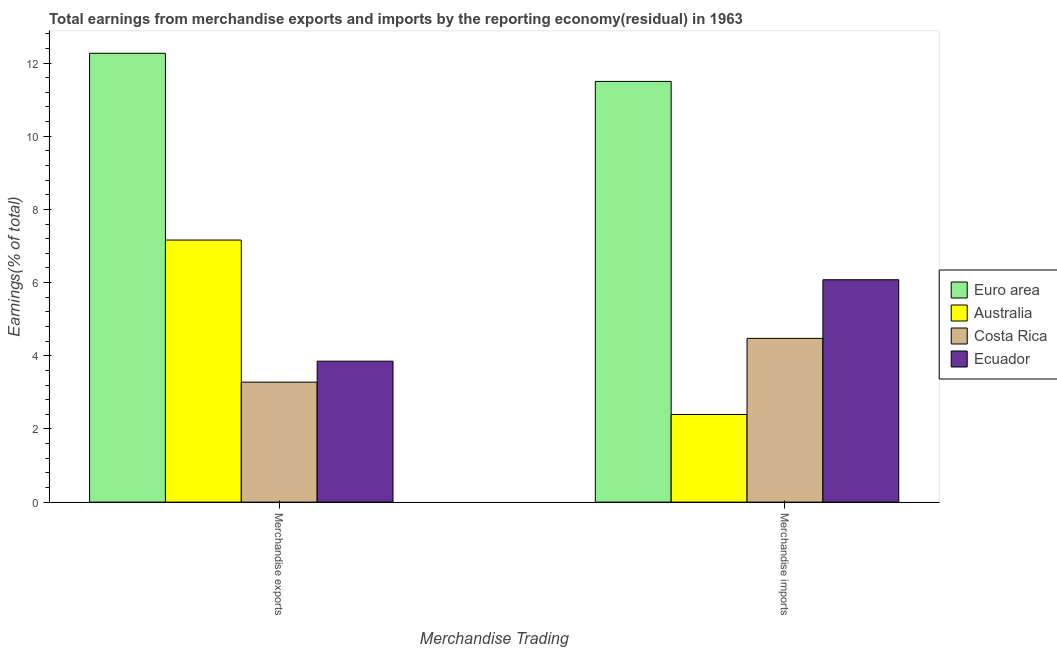How many different coloured bars are there?
Ensure brevity in your answer.  4. How many groups of bars are there?
Your answer should be very brief. 2. Are the number of bars per tick equal to the number of legend labels?
Offer a terse response. Yes. What is the earnings from merchandise exports in Euro area?
Offer a very short reply. 12.27. Across all countries, what is the maximum earnings from merchandise exports?
Your answer should be compact. 12.27. Across all countries, what is the minimum earnings from merchandise imports?
Provide a succinct answer. 2.4. In which country was the earnings from merchandise exports minimum?
Your answer should be compact. Costa Rica. What is the total earnings from merchandise imports in the graph?
Give a very brief answer. 24.45. What is the difference between the earnings from merchandise exports in Ecuador and that in Australia?
Keep it short and to the point. -3.31. What is the difference between the earnings from merchandise imports in Costa Rica and the earnings from merchandise exports in Australia?
Your response must be concise. -2.69. What is the average earnings from merchandise exports per country?
Offer a very short reply. 6.64. What is the difference between the earnings from merchandise imports and earnings from merchandise exports in Ecuador?
Offer a terse response. 2.23. What is the ratio of the earnings from merchandise exports in Costa Rica to that in Ecuador?
Provide a succinct answer. 0.85. How many countries are there in the graph?
Offer a very short reply. 4. Does the graph contain any zero values?
Provide a short and direct response. No. Where does the legend appear in the graph?
Give a very brief answer. Center right. How many legend labels are there?
Make the answer very short. 4. How are the legend labels stacked?
Your answer should be compact. Vertical. What is the title of the graph?
Provide a short and direct response. Total earnings from merchandise exports and imports by the reporting economy(residual) in 1963. What is the label or title of the X-axis?
Your answer should be compact. Merchandise Trading. What is the label or title of the Y-axis?
Your answer should be compact. Earnings(% of total). What is the Earnings(% of total) of Euro area in Merchandise exports?
Make the answer very short. 12.27. What is the Earnings(% of total) in Australia in Merchandise exports?
Your response must be concise. 7.16. What is the Earnings(% of total) of Costa Rica in Merchandise exports?
Make the answer very short. 3.28. What is the Earnings(% of total) in Ecuador in Merchandise exports?
Give a very brief answer. 3.85. What is the Earnings(% of total) in Euro area in Merchandise imports?
Offer a very short reply. 11.5. What is the Earnings(% of total) in Australia in Merchandise imports?
Ensure brevity in your answer.  2.4. What is the Earnings(% of total) in Costa Rica in Merchandise imports?
Make the answer very short. 4.48. What is the Earnings(% of total) in Ecuador in Merchandise imports?
Keep it short and to the point. 6.08. Across all Merchandise Trading, what is the maximum Earnings(% of total) of Euro area?
Your answer should be very brief. 12.27. Across all Merchandise Trading, what is the maximum Earnings(% of total) in Australia?
Keep it short and to the point. 7.16. Across all Merchandise Trading, what is the maximum Earnings(% of total) in Costa Rica?
Give a very brief answer. 4.48. Across all Merchandise Trading, what is the maximum Earnings(% of total) of Ecuador?
Make the answer very short. 6.08. Across all Merchandise Trading, what is the minimum Earnings(% of total) of Euro area?
Offer a very short reply. 11.5. Across all Merchandise Trading, what is the minimum Earnings(% of total) of Australia?
Provide a short and direct response. 2.4. Across all Merchandise Trading, what is the minimum Earnings(% of total) of Costa Rica?
Your response must be concise. 3.28. Across all Merchandise Trading, what is the minimum Earnings(% of total) of Ecuador?
Provide a short and direct response. 3.85. What is the total Earnings(% of total) in Euro area in the graph?
Your response must be concise. 23.76. What is the total Earnings(% of total) of Australia in the graph?
Keep it short and to the point. 9.56. What is the total Earnings(% of total) in Costa Rica in the graph?
Give a very brief answer. 7.75. What is the total Earnings(% of total) in Ecuador in the graph?
Provide a short and direct response. 9.93. What is the difference between the Earnings(% of total) of Euro area in Merchandise exports and that in Merchandise imports?
Your answer should be compact. 0.77. What is the difference between the Earnings(% of total) of Australia in Merchandise exports and that in Merchandise imports?
Offer a terse response. 4.77. What is the difference between the Earnings(% of total) in Costa Rica in Merchandise exports and that in Merchandise imports?
Your answer should be compact. -1.2. What is the difference between the Earnings(% of total) of Ecuador in Merchandise exports and that in Merchandise imports?
Provide a succinct answer. -2.23. What is the difference between the Earnings(% of total) in Euro area in Merchandise exports and the Earnings(% of total) in Australia in Merchandise imports?
Provide a short and direct response. 9.87. What is the difference between the Earnings(% of total) in Euro area in Merchandise exports and the Earnings(% of total) in Costa Rica in Merchandise imports?
Make the answer very short. 7.79. What is the difference between the Earnings(% of total) in Euro area in Merchandise exports and the Earnings(% of total) in Ecuador in Merchandise imports?
Provide a succinct answer. 6.19. What is the difference between the Earnings(% of total) in Australia in Merchandise exports and the Earnings(% of total) in Costa Rica in Merchandise imports?
Offer a terse response. 2.69. What is the difference between the Earnings(% of total) of Australia in Merchandise exports and the Earnings(% of total) of Ecuador in Merchandise imports?
Provide a succinct answer. 1.08. What is the difference between the Earnings(% of total) in Costa Rica in Merchandise exports and the Earnings(% of total) in Ecuador in Merchandise imports?
Make the answer very short. -2.8. What is the average Earnings(% of total) of Euro area per Merchandise Trading?
Ensure brevity in your answer.  11.88. What is the average Earnings(% of total) of Australia per Merchandise Trading?
Provide a short and direct response. 4.78. What is the average Earnings(% of total) in Costa Rica per Merchandise Trading?
Offer a terse response. 3.88. What is the average Earnings(% of total) in Ecuador per Merchandise Trading?
Your response must be concise. 4.96. What is the difference between the Earnings(% of total) in Euro area and Earnings(% of total) in Australia in Merchandise exports?
Provide a short and direct response. 5.1. What is the difference between the Earnings(% of total) in Euro area and Earnings(% of total) in Costa Rica in Merchandise exports?
Make the answer very short. 8.99. What is the difference between the Earnings(% of total) of Euro area and Earnings(% of total) of Ecuador in Merchandise exports?
Your response must be concise. 8.41. What is the difference between the Earnings(% of total) of Australia and Earnings(% of total) of Costa Rica in Merchandise exports?
Ensure brevity in your answer.  3.88. What is the difference between the Earnings(% of total) in Australia and Earnings(% of total) in Ecuador in Merchandise exports?
Provide a short and direct response. 3.31. What is the difference between the Earnings(% of total) in Costa Rica and Earnings(% of total) in Ecuador in Merchandise exports?
Offer a terse response. -0.57. What is the difference between the Earnings(% of total) in Euro area and Earnings(% of total) in Australia in Merchandise imports?
Your answer should be compact. 9.1. What is the difference between the Earnings(% of total) in Euro area and Earnings(% of total) in Costa Rica in Merchandise imports?
Ensure brevity in your answer.  7.02. What is the difference between the Earnings(% of total) of Euro area and Earnings(% of total) of Ecuador in Merchandise imports?
Your response must be concise. 5.42. What is the difference between the Earnings(% of total) of Australia and Earnings(% of total) of Costa Rica in Merchandise imports?
Your response must be concise. -2.08. What is the difference between the Earnings(% of total) in Australia and Earnings(% of total) in Ecuador in Merchandise imports?
Your answer should be very brief. -3.68. What is the difference between the Earnings(% of total) in Costa Rica and Earnings(% of total) in Ecuador in Merchandise imports?
Give a very brief answer. -1.6. What is the ratio of the Earnings(% of total) of Euro area in Merchandise exports to that in Merchandise imports?
Make the answer very short. 1.07. What is the ratio of the Earnings(% of total) of Australia in Merchandise exports to that in Merchandise imports?
Offer a terse response. 2.99. What is the ratio of the Earnings(% of total) in Costa Rica in Merchandise exports to that in Merchandise imports?
Ensure brevity in your answer.  0.73. What is the ratio of the Earnings(% of total) of Ecuador in Merchandise exports to that in Merchandise imports?
Make the answer very short. 0.63. What is the difference between the highest and the second highest Earnings(% of total) in Euro area?
Give a very brief answer. 0.77. What is the difference between the highest and the second highest Earnings(% of total) of Australia?
Give a very brief answer. 4.77. What is the difference between the highest and the second highest Earnings(% of total) of Costa Rica?
Keep it short and to the point. 1.2. What is the difference between the highest and the second highest Earnings(% of total) of Ecuador?
Your answer should be compact. 2.23. What is the difference between the highest and the lowest Earnings(% of total) of Euro area?
Your answer should be compact. 0.77. What is the difference between the highest and the lowest Earnings(% of total) in Australia?
Give a very brief answer. 4.77. What is the difference between the highest and the lowest Earnings(% of total) of Costa Rica?
Offer a very short reply. 1.2. What is the difference between the highest and the lowest Earnings(% of total) of Ecuador?
Provide a succinct answer. 2.23. 